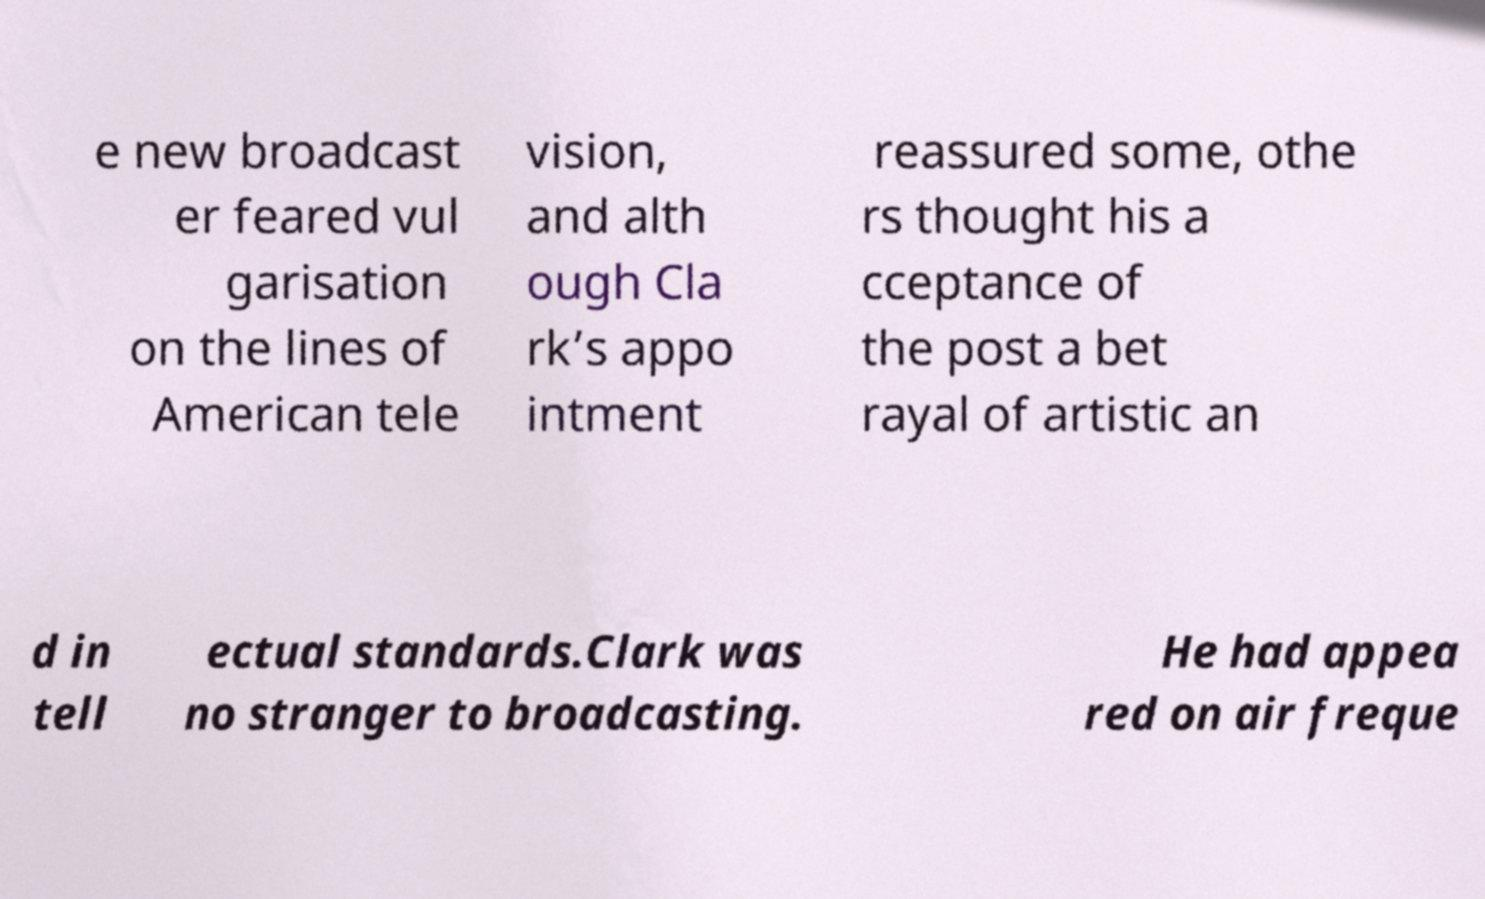Could you extract and type out the text from this image? e new broadcast er feared vul garisation on the lines of American tele vision, and alth ough Cla rk’s appo intment reassured some, othe rs thought his a cceptance of the post a bet rayal of artistic an d in tell ectual standards.Clark was no stranger to broadcasting. He had appea red on air freque 